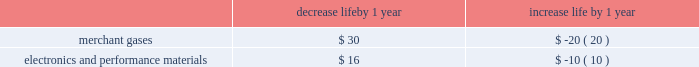The depreciable lives of production facilities within the merchant gases segment are principally 15 years .
Customer contracts associated with products produced at these types of facilities typically have a much shorter term .
The depreciable lives of production facilities within the electronics and performance materials segment , where there is not an associated long-term supply agreement , range from 10 to 15 years .
These depreciable lives have been determined based on historical experience combined with judgment on future assumptions such as technological advances , potential obsolescence , competitors 2019 actions , etc .
Management monitors its assumptions and may potentially need to adjust depreciable life as circumstances change .
A change in the depreciable life by one year for production facilities within the merchant gases and electronics and performance materials segments for which there is not an associated long-term customer supply agreement would impact annual depreciation expense as summarized below : decrease life by 1 year increase life by 1 year .
Impairment of assets plant and equipment plant and equipment held for use is grouped for impairment testing at the lowest level for which there are identifiable cash flows .
Impairment testing of the asset group occurs whenever events or changes in circumstances indicate that the carrying amount of the assets may not be recoverable .
Such circumstances would include a significant decrease in the market value of a long-lived asset grouping , a significant adverse change in the manner in which the asset grouping is being used or in its physical condition , a history of operating or cash flow losses associated with the use of the asset grouping , or changes in the expected useful life of the long-lived assets .
If such circumstances are determined to exist , an estimate of undiscounted future cash flows produced by that asset group is compared to the carrying value to determine whether impairment exists .
If an asset group is determined to be impaired , the loss is measured based on the difference between the asset group 2019s fair value and its carrying value .
An estimate of the asset group 2019s fair value is based on the discounted value of its estimated cash flows .
Assets to be disposed of by sale are reported at the lower of carrying amount or fair value less cost to sell .
The assumptions underlying cash flow projections represent management 2019s best estimates at the time of the impairment review .
Factors that management must estimate include industry and market conditions , sales volume and prices , costs to produce , inflation , etc .
Changes in key assumptions or actual conditions that differ from estimates could result in an impairment charge .
We use reasonable and supportable assumptions when performing impairment reviews and cannot predict the occurrence of future events and circumstances that could result in impairment charges .
Goodwill the acquisition method of accounting for business combinations currently requires us to make use of estimates and judgments to allocate the purchase price paid for acquisitions to the fair value of the net tangible and identifiable intangible assets .
Goodwill represents the excess of the aggregate purchase price over the fair value of net assets of an acquired entity .
Goodwill , including goodwill associated with equity affiliates of $ 126.4 , was $ 1780.2 as of 30 september 2013 .
The majority of our goodwill is assigned to reporting units within the merchant gases and electronics and performance materials segments .
Goodwill increased in 2013 , primarily as a result of the epco and wcg acquisitions in merchant gases during the third quarter .
Disclosures related to goodwill are included in note 10 , goodwill , to the consolidated financial statements .
We perform an impairment test annually in the fourth quarter of the fiscal year .
In addition , goodwill would be tested more frequently if changes in circumstances or the occurrence of events indicated that potential impairment exists .
The tests are done at the reporting unit level , which is defined as one level below the operating segment for which discrete financial information is available and whose operating results are reviewed by segment managers regularly .
Currently , we have four business segments and thirteen reporting units .
Reporting units are primarily based on products and geographic locations within each business segment .
As part of the goodwill impairment testing , and as permitted under the accounting guidance , we have the option to first assess qualitative factors to determine whether it is more likely than not that the fair value of a reporting unit is less than its carrying value .
If we choose not to complete a qualitative assessment for a given reporting unit , or if the .
What is the depreciation expense with the production facilities within the electronics and performance materials segment accumulated in 10 years? 
Rationale: it is the number of years expected in its depreciable life multiplied by the increased life by a 1-year value .
Computations: (10 * 10)
Answer: 100.0. 